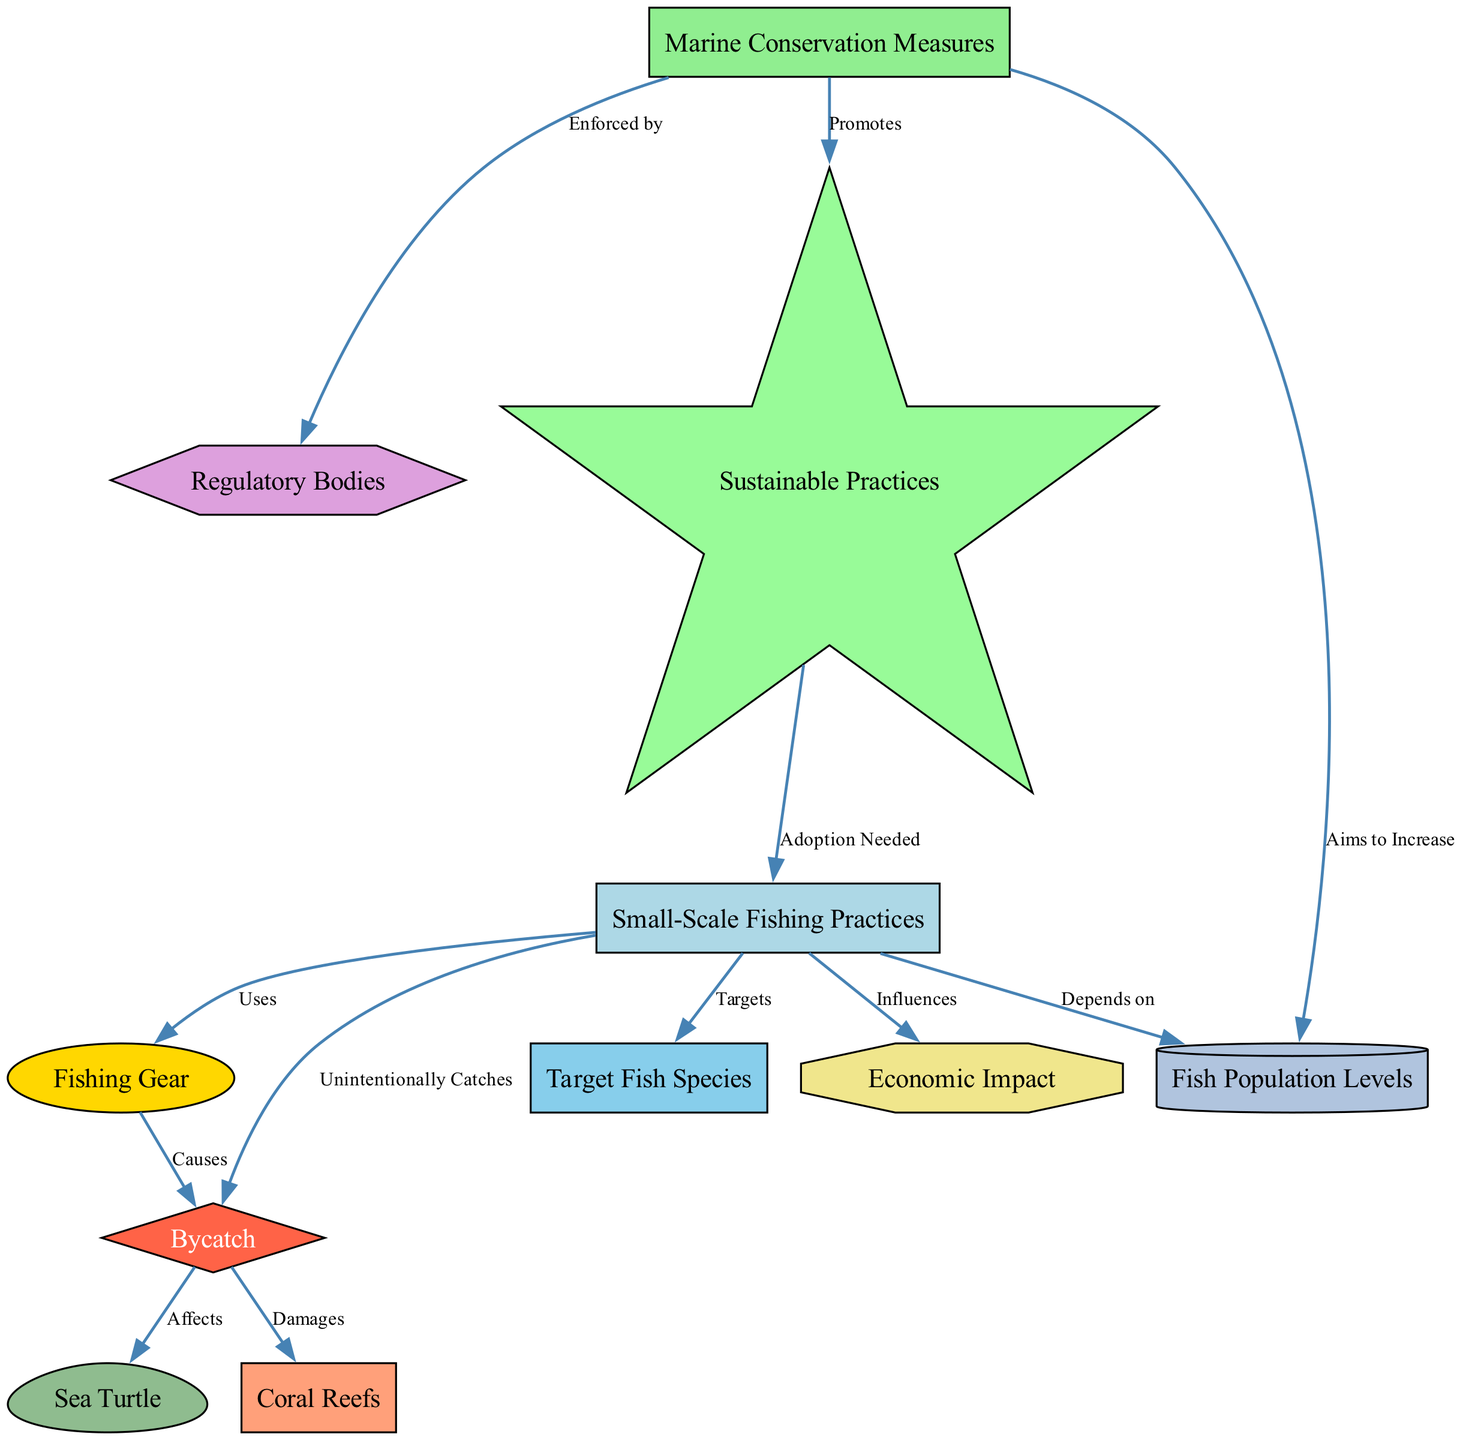What nodes are connected to "Small-Scale Fishing Practices"? The diagram shows three connections originating from "Small-Scale Fishing Practices": it connects to "Fishing Gear," "Target Fish Species," and "Bycatch." Each of these has a specific relationship indicated by the edges.
Answer: Fishing Gear, Target Fish Species, Bycatch What affects "Bycatch"? "Bycatch" is affected by two nodes: "Sea Turtle" and "Coral Reefs." This is illustrated by the arrows pointing from "Bycatch" to these two nodes in the diagram.
Answer: Sea Turtle, Coral Reefs How many nodes are there in the diagram? By counting the number of unique labeled shapes in the diagram, we can identify that there are 11 nodes total, each representing different concepts associated with marine wildlife and fishing practices.
Answer: 11 What does "Marine Conservation Measures" aim to increase? According to the diagram, "Marine Conservation Measures" aims to increase "Fish Population Levels." This relationship is shown by an arrow leading from "Marine Conservation Measures" to "Fish Population Levels."
Answer: Fish Population Levels What do "Small-Scale Fishing Practices" influence? The influence of "Small-Scale Fishing Practices" extends to "Economic Impact." The diagram clearly indicates this with an edge connecting the two, indicating a direct relationship.
Answer: Economic Impact What promotes "Sustainable Practices"? The diagram indicates that "Marine Conservation Measures" promotes "Sustainable Practices." This is evidenced by the directed edge connecting the two nodes, highlighting the relationship.
Answer: Sustainable Practices What is the relationship between "Fishing Gear" and "Bycatch"? "Fishing Gear" causes "Bycatch," as shown by the directed edge from "Fishing Gear" to "Bycatch." This indicates that the type of fishing gear used influences the occurrence of bycatch.
Answer: Causes Which regulatory body enforces marine conservation measures? "Regulatory Bodies" enforce "Marine Conservation Measures," as depicted by the edge from "Regulatory Bodies" leading to "Marine Conservation Measures" in the diagram.
Answer: Regulatory Bodies 